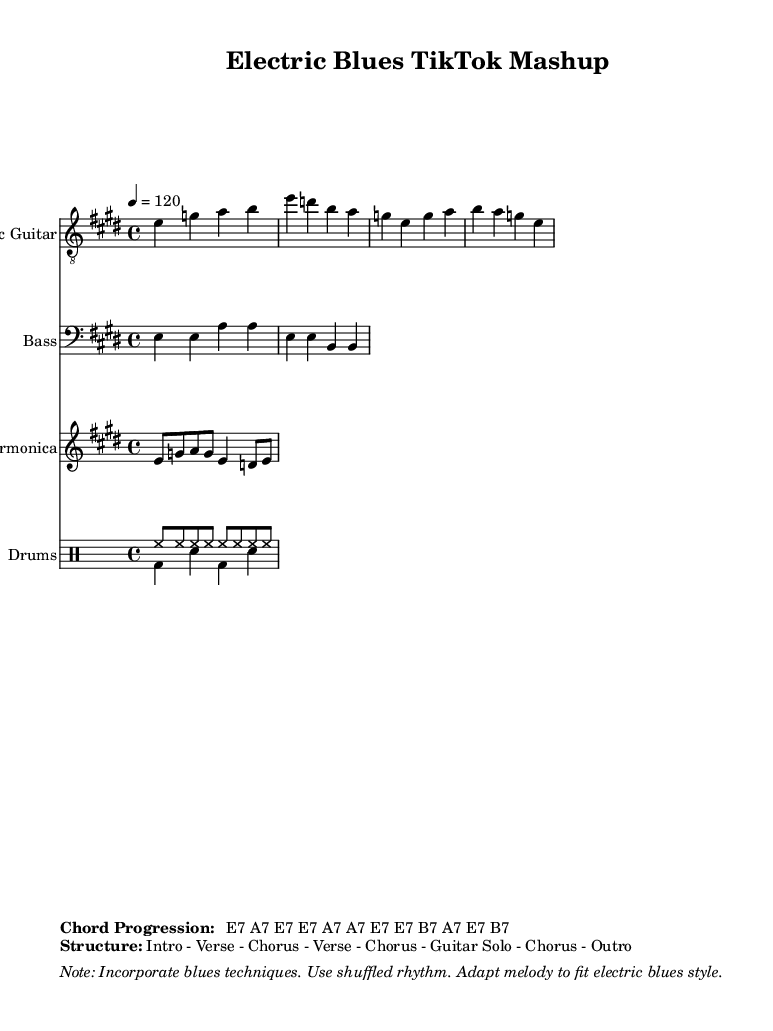What is the key signature of this music? The key signature is indicated by the sharp symbols placed at the beginning of the staff, which, in this case, corresponds to E major since it has four sharps (F#, C#, G#, and D#).
Answer: E major What is the time signature of this music? The time signature is shown at the beginning of the score and indicates how many beats are in each measure. Here, it is presented as 4/4, meaning there are four beats in each measure.
Answer: 4/4 What is the tempo marking for this piece? The tempo marking is provided as a number and a note type at the beginning, indicating the speed of the music. In this case, it states "4 = 120", meaning there are 120 beats per minute.
Answer: 120 What chord progression is used in this music? The chord progression is shown in the markup section, outlining the sequence of chords that accompany the melody. It reads E7 A7 E7 E7 A7 A7 E7 E7 B7 A7 E7 B7.
Answer: E7 A7 E7 E7 A7 A7 E7 E7 B7 A7 E7 B7 What is the overall structure of this piece? The structure is detailed in the markup section, specifying the arrangement of sections within the music. It notes that the piece follows Intro - Verse - Chorus - Verse - Chorus - Guitar Solo - Chorus - Outro.
Answer: Intro - Verse - Chorus - Verse - Chorus - Guitar Solo - Chorus - Outro Which instrument plays the melody? The score indicates that the "Electric Guitar" staff contains the main melodic line, as it is set to be played in the treble clef and often carries the lead part in blues music.
Answer: Electric Guitar What special techniques should be incorporated based on the markup note? The markup includes specific instructions about techniques that should be used in performing the piece, such as incorporating blues techniques, using shuffled rhythm, and adapting the melody to fit the electric blues style.
Answer: Blues techniques, shuffled rhythm 